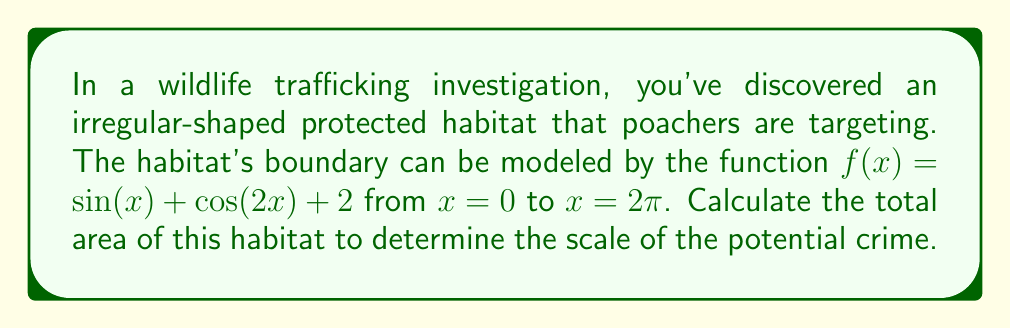Provide a solution to this math problem. To calculate the area of this irregular-shaped habitat, we need to use integration. The area under a curve from $a$ to $b$ is given by the definite integral:

$$A = \int_a^b f(x) dx$$

In this case, $f(x) = \sin(x) + \cos(2x) + 2$, $a = 0$, and $b = 2\pi$. Let's solve this step-by-step:

1) Set up the integral:
   $$A = \int_0^{2\pi} (\sin(x) + \cos(2x) + 2) dx$$

2) Integrate each term separately:
   $$A = \left[-\cos(x) + \frac{1}{2}\sin(2x) + 2x\right]_0^{2\pi}$$

3) Evaluate the antiderivative at the limits:
   $$A = \left[-\cos(2\pi) + \frac{1}{2}\sin(4\pi) + 4\pi\right] - \left[-\cos(0) + \frac{1}{2}\sin(0) + 0\right]$$

4) Simplify:
   $$A = \left[-1 + 0 + 4\pi\right] - \left[-1 + 0 + 0\right]$$
   $$A = (-1 + 4\pi) - (-1)$$
   $$A = 4\pi$$

Therefore, the total area of the habitat is $4\pi$ square units.
Answer: $4\pi$ square units 